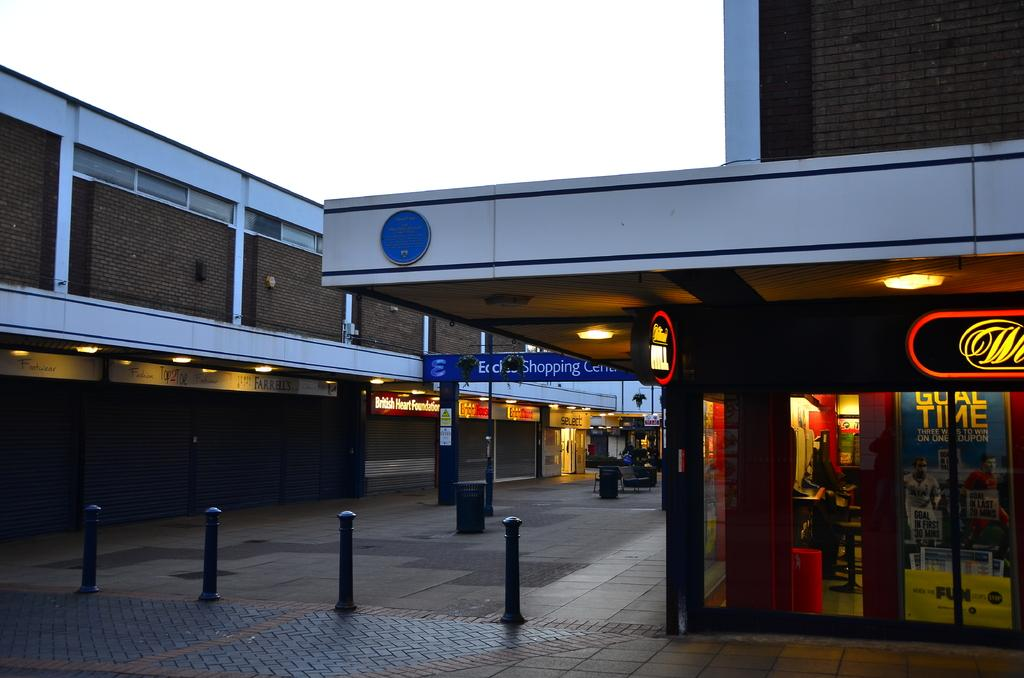<image>
Render a clear and concise summary of the photo. An outdoor mall with stores to shop and one is a sports shop that advertises Goal time in the window. 